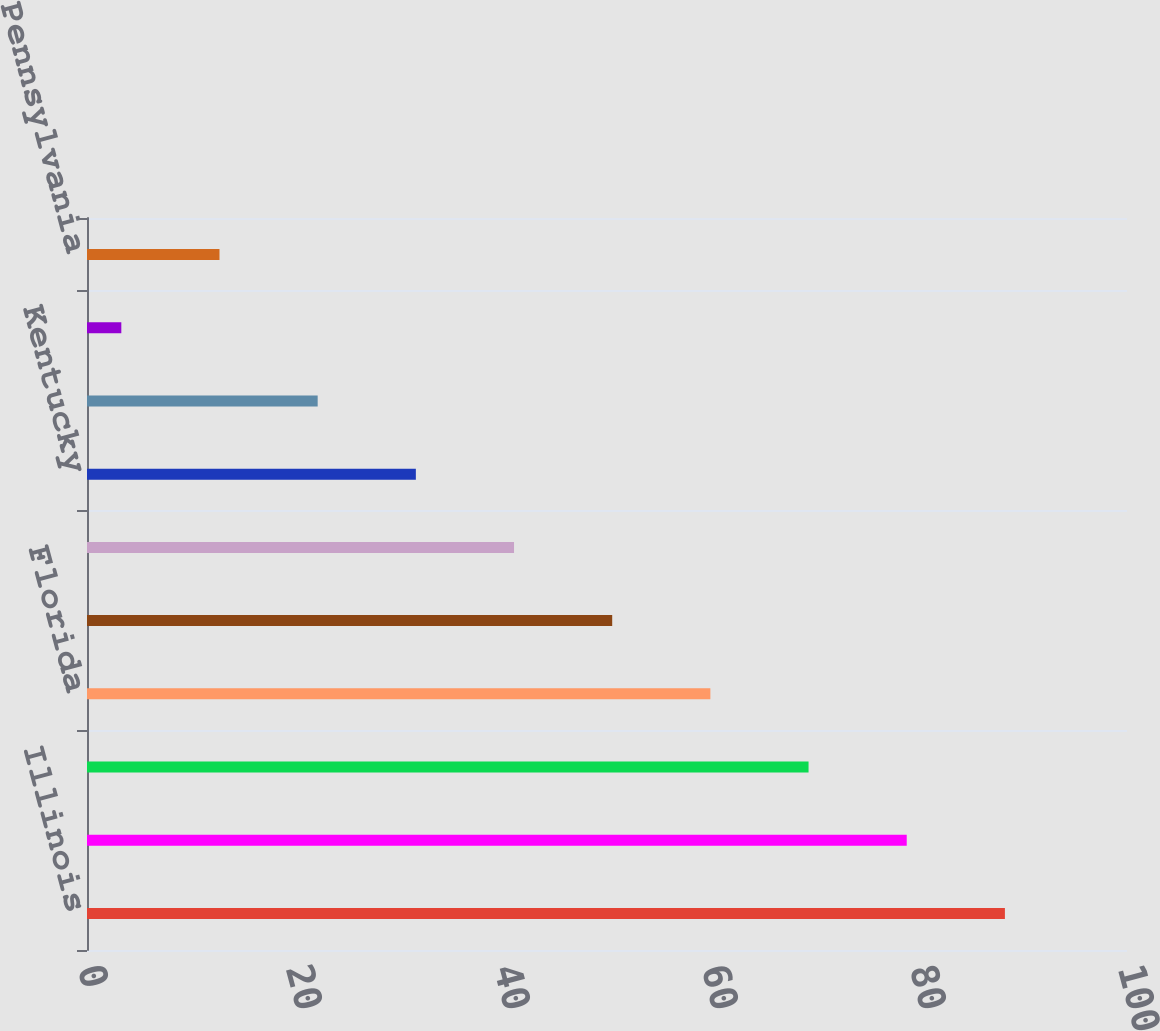Convert chart. <chart><loc_0><loc_0><loc_500><loc_500><bar_chart><fcel>Illinois<fcel>California<fcel>Massachusetts<fcel>Florida<fcel>Indiana<fcel>Ohio<fcel>Kentucky<fcel>North Carolina<fcel>Texas<fcel>Pennsylvania<nl><fcel>88.26<fcel>78.82<fcel>69.38<fcel>59.94<fcel>50.5<fcel>41.06<fcel>31.62<fcel>22.18<fcel>3.3<fcel>12.74<nl></chart> 